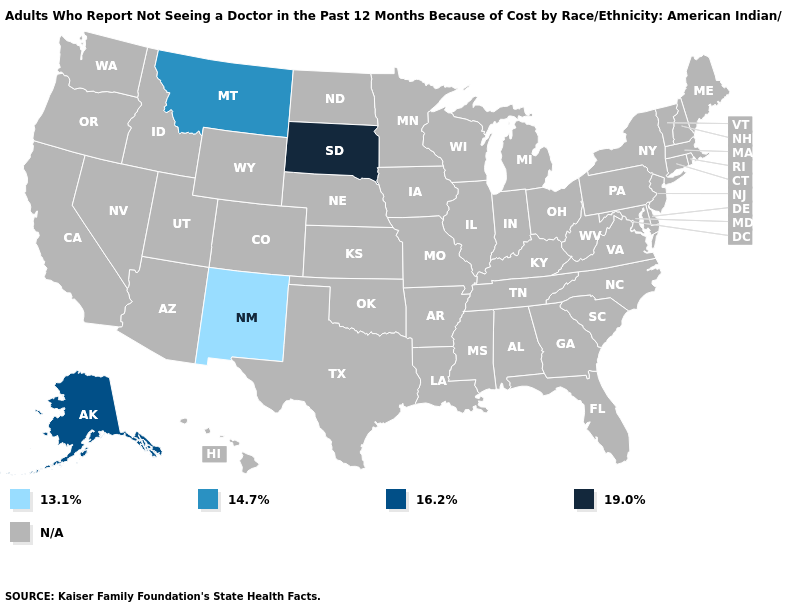What is the value of California?
Short answer required. N/A. Which states have the highest value in the USA?
Write a very short answer. South Dakota. What is the lowest value in the USA?
Short answer required. 13.1%. Does Montana have the highest value in the West?
Short answer required. No. What is the value of Georgia?
Write a very short answer. N/A. Name the states that have a value in the range 14.7%?
Answer briefly. Montana. What is the value of West Virginia?
Answer briefly. N/A. What is the value of Vermont?
Answer briefly. N/A. 